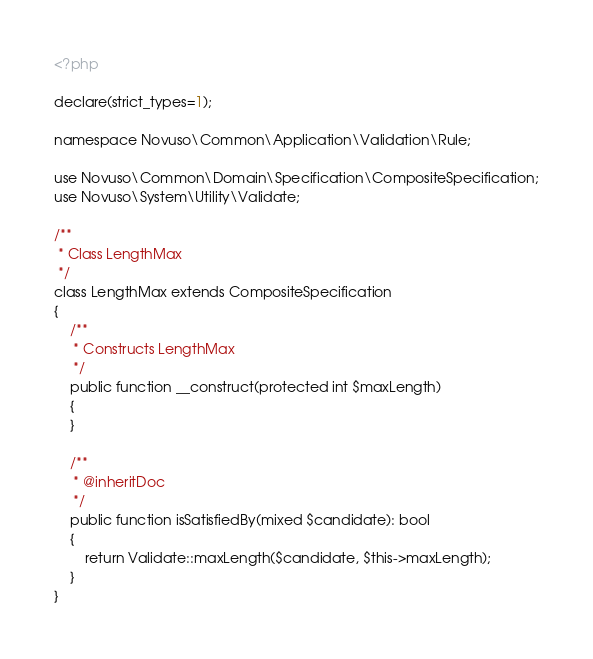<code> <loc_0><loc_0><loc_500><loc_500><_PHP_><?php

declare(strict_types=1);

namespace Novuso\Common\Application\Validation\Rule;

use Novuso\Common\Domain\Specification\CompositeSpecification;
use Novuso\System\Utility\Validate;

/**
 * Class LengthMax
 */
class LengthMax extends CompositeSpecification
{
    /**
     * Constructs LengthMax
     */
    public function __construct(protected int $maxLength)
    {
    }

    /**
     * @inheritDoc
     */
    public function isSatisfiedBy(mixed $candidate): bool
    {
        return Validate::maxLength($candidate, $this->maxLength);
    }
}
</code> 